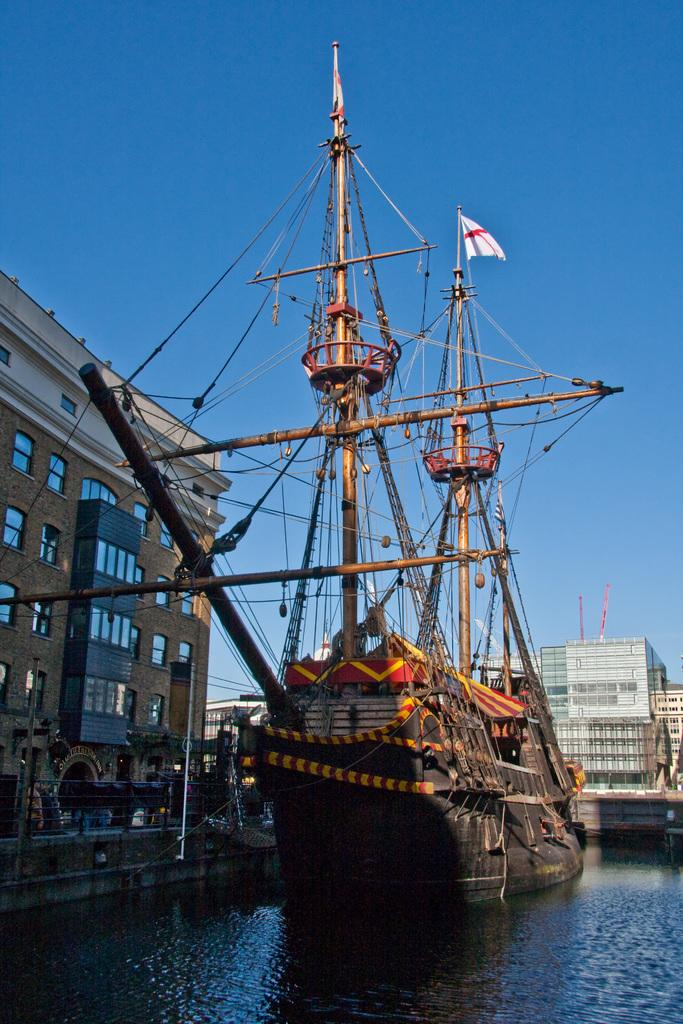What is the main subject of the image? The main subject of the image is a ship. Where is the ship located in the image? The ship is on a river. What can be seen in the background of the image? There are buildings and the sky visible in the background of the image. What type of heat is being generated by the ship in the image? There is no indication of heat generation in the image, as it features a ship on a river with buildings and the sky in the background. 